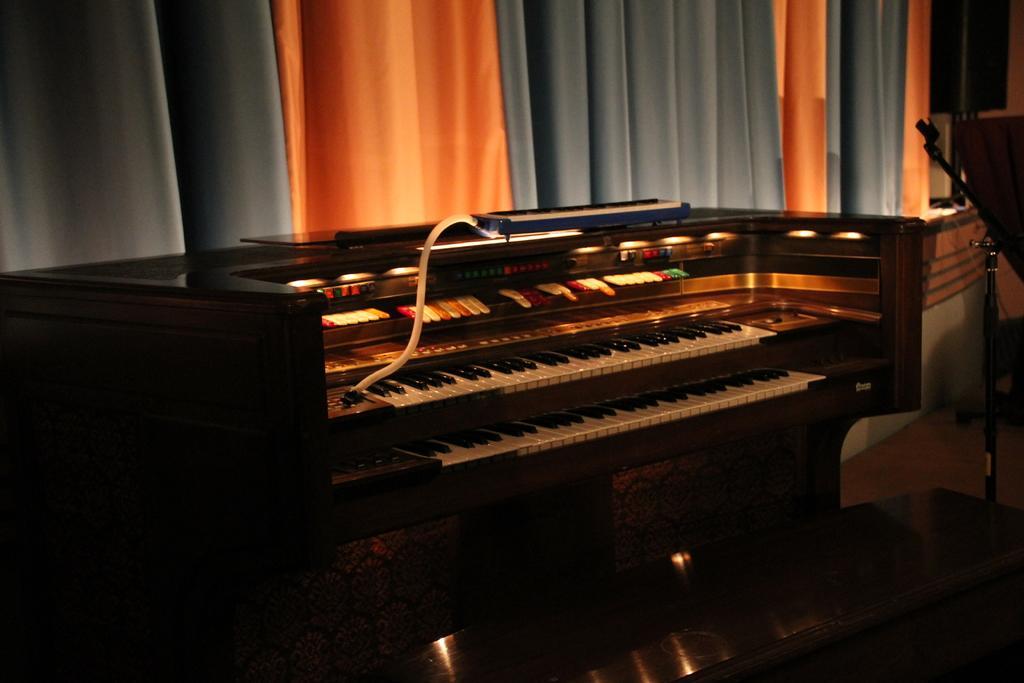Please provide a concise description of this image. In this picture there is a piano, the keys of the piano are in different colors. On the piano there is a tube. In the background there is a curtain. Towards the right there is a stand. 